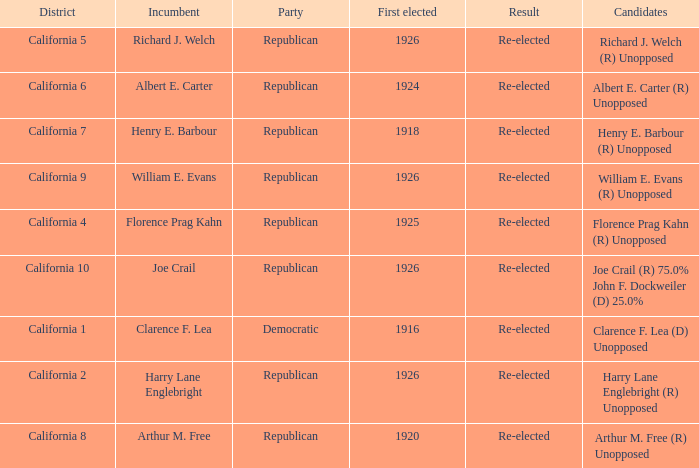Would you be able to parse every entry in this table? {'header': ['District', 'Incumbent', 'Party', 'First elected', 'Result', 'Candidates'], 'rows': [['California 5', 'Richard J. Welch', 'Republican', '1926', 'Re-elected', 'Richard J. Welch (R) Unopposed'], ['California 6', 'Albert E. Carter', 'Republican', '1924', 'Re-elected', 'Albert E. Carter (R) Unopposed'], ['California 7', 'Henry E. Barbour', 'Republican', '1918', 'Re-elected', 'Henry E. Barbour (R) Unopposed'], ['California 9', 'William E. Evans', 'Republican', '1926', 'Re-elected', 'William E. Evans (R) Unopposed'], ['California 4', 'Florence Prag Kahn', 'Republican', '1925', 'Re-elected', 'Florence Prag Kahn (R) Unopposed'], ['California 10', 'Joe Crail', 'Republican', '1926', 'Re-elected', 'Joe Crail (R) 75.0% John F. Dockweiler (D) 25.0%'], ['California 1', 'Clarence F. Lea', 'Democratic', '1916', 'Re-elected', 'Clarence F. Lea (D) Unopposed'], ['California 2', 'Harry Lane Englebright', 'Republican', '1926', 'Re-elected', 'Harry Lane Englebright (R) Unopposed'], ['California 8', 'Arthur M. Free', 'Republican', '1920', 'Re-elected', 'Arthur M. Free (R) Unopposed']]} What's the party with incumbent being william e. evans Republican. 